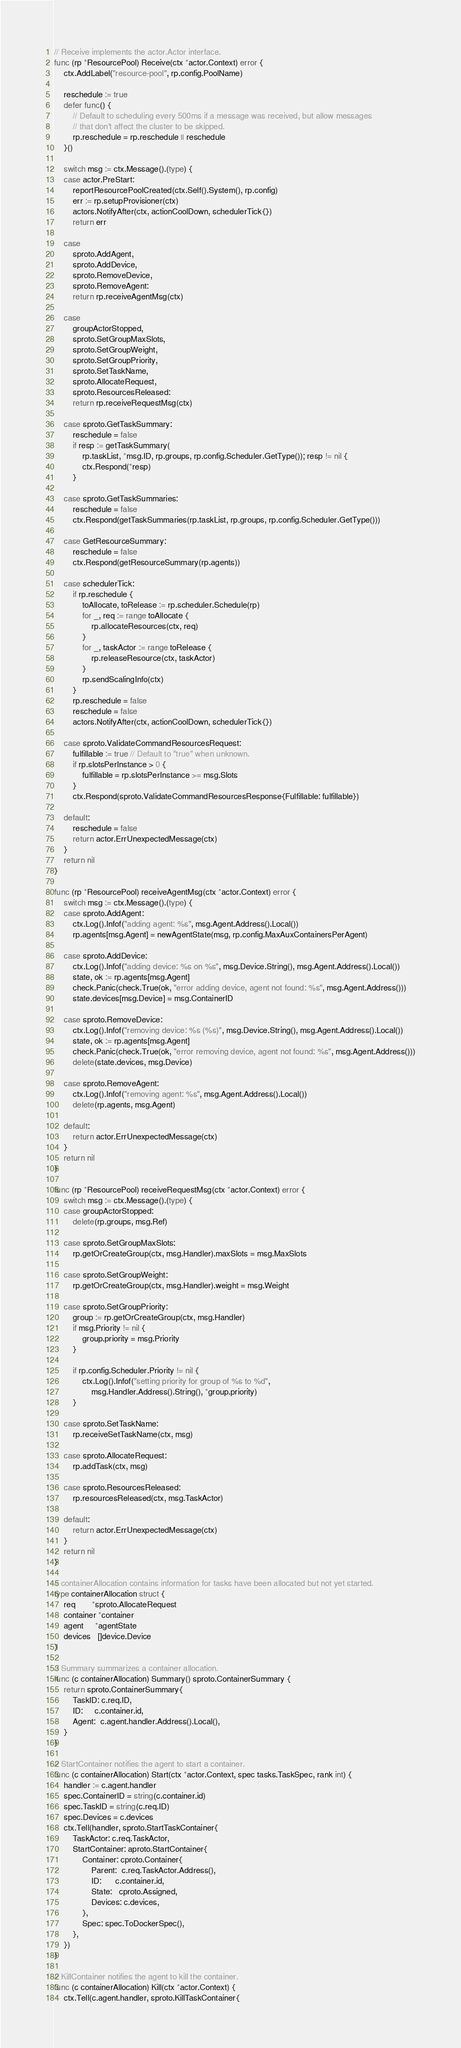<code> <loc_0><loc_0><loc_500><loc_500><_Go_>
// Receive implements the actor.Actor interface.
func (rp *ResourcePool) Receive(ctx *actor.Context) error {
	ctx.AddLabel("resource-pool", rp.config.PoolName)

	reschedule := true
	defer func() {
		// Default to scheduling every 500ms if a message was received, but allow messages
		// that don't affect the cluster to be skipped.
		rp.reschedule = rp.reschedule || reschedule
	}()

	switch msg := ctx.Message().(type) {
	case actor.PreStart:
		reportResourcePoolCreated(ctx.Self().System(), rp.config)
		err := rp.setupProvisioner(ctx)
		actors.NotifyAfter(ctx, actionCoolDown, schedulerTick{})
		return err

	case
		sproto.AddAgent,
		sproto.AddDevice,
		sproto.RemoveDevice,
		sproto.RemoveAgent:
		return rp.receiveAgentMsg(ctx)

	case
		groupActorStopped,
		sproto.SetGroupMaxSlots,
		sproto.SetGroupWeight,
		sproto.SetGroupPriority,
		sproto.SetTaskName,
		sproto.AllocateRequest,
		sproto.ResourcesReleased:
		return rp.receiveRequestMsg(ctx)

	case sproto.GetTaskSummary:
		reschedule = false
		if resp := getTaskSummary(
			rp.taskList, *msg.ID, rp.groups, rp.config.Scheduler.GetType()); resp != nil {
			ctx.Respond(*resp)
		}

	case sproto.GetTaskSummaries:
		reschedule = false
		ctx.Respond(getTaskSummaries(rp.taskList, rp.groups, rp.config.Scheduler.GetType()))

	case GetResourceSummary:
		reschedule = false
		ctx.Respond(getResourceSummary(rp.agents))

	case schedulerTick:
		if rp.reschedule {
			toAllocate, toRelease := rp.scheduler.Schedule(rp)
			for _, req := range toAllocate {
				rp.allocateResources(ctx, req)
			}
			for _, taskActor := range toRelease {
				rp.releaseResource(ctx, taskActor)
			}
			rp.sendScalingInfo(ctx)
		}
		rp.reschedule = false
		reschedule = false
		actors.NotifyAfter(ctx, actionCoolDown, schedulerTick{})

	case sproto.ValidateCommandResourcesRequest:
		fulfillable := true // Default to "true" when unknown.
		if rp.slotsPerInstance > 0 {
			fulfillable = rp.slotsPerInstance >= msg.Slots
		}
		ctx.Respond(sproto.ValidateCommandResourcesResponse{Fulfillable: fulfillable})

	default:
		reschedule = false
		return actor.ErrUnexpectedMessage(ctx)
	}
	return nil
}

func (rp *ResourcePool) receiveAgentMsg(ctx *actor.Context) error {
	switch msg := ctx.Message().(type) {
	case sproto.AddAgent:
		ctx.Log().Infof("adding agent: %s", msg.Agent.Address().Local())
		rp.agents[msg.Agent] = newAgentState(msg, rp.config.MaxAuxContainersPerAgent)

	case sproto.AddDevice:
		ctx.Log().Infof("adding device: %s on %s", msg.Device.String(), msg.Agent.Address().Local())
		state, ok := rp.agents[msg.Agent]
		check.Panic(check.True(ok, "error adding device, agent not found: %s", msg.Agent.Address()))
		state.devices[msg.Device] = msg.ContainerID

	case sproto.RemoveDevice:
		ctx.Log().Infof("removing device: %s (%s)", msg.Device.String(), msg.Agent.Address().Local())
		state, ok := rp.agents[msg.Agent]
		check.Panic(check.True(ok, "error removing device, agent not found: %s", msg.Agent.Address()))
		delete(state.devices, msg.Device)

	case sproto.RemoveAgent:
		ctx.Log().Infof("removing agent: %s", msg.Agent.Address().Local())
		delete(rp.agents, msg.Agent)

	default:
		return actor.ErrUnexpectedMessage(ctx)
	}
	return nil
}

func (rp *ResourcePool) receiveRequestMsg(ctx *actor.Context) error {
	switch msg := ctx.Message().(type) {
	case groupActorStopped:
		delete(rp.groups, msg.Ref)

	case sproto.SetGroupMaxSlots:
		rp.getOrCreateGroup(ctx, msg.Handler).maxSlots = msg.MaxSlots

	case sproto.SetGroupWeight:
		rp.getOrCreateGroup(ctx, msg.Handler).weight = msg.Weight

	case sproto.SetGroupPriority:
		group := rp.getOrCreateGroup(ctx, msg.Handler)
		if msg.Priority != nil {
			group.priority = msg.Priority
		}

		if rp.config.Scheduler.Priority != nil {
			ctx.Log().Infof("setting priority for group of %s to %d",
				msg.Handler.Address().String(), *group.priority)
		}

	case sproto.SetTaskName:
		rp.receiveSetTaskName(ctx, msg)

	case sproto.AllocateRequest:
		rp.addTask(ctx, msg)

	case sproto.ResourcesReleased:
		rp.resourcesReleased(ctx, msg.TaskActor)

	default:
		return actor.ErrUnexpectedMessage(ctx)
	}
	return nil
}

// containerAllocation contains information for tasks have been allocated but not yet started.
type containerAllocation struct {
	req       *sproto.AllocateRequest
	container *container
	agent     *agentState
	devices   []device.Device
}

// Summary summarizes a container allocation.
func (c containerAllocation) Summary() sproto.ContainerSummary {
	return sproto.ContainerSummary{
		TaskID: c.req.ID,
		ID:     c.container.id,
		Agent:  c.agent.handler.Address().Local(),
	}
}

// StartContainer notifies the agent to start a container.
func (c containerAllocation) Start(ctx *actor.Context, spec tasks.TaskSpec, rank int) {
	handler := c.agent.handler
	spec.ContainerID = string(c.container.id)
	spec.TaskID = string(c.req.ID)
	spec.Devices = c.devices
	ctx.Tell(handler, sproto.StartTaskContainer{
		TaskActor: c.req.TaskActor,
		StartContainer: aproto.StartContainer{
			Container: cproto.Container{
				Parent:  c.req.TaskActor.Address(),
				ID:      c.container.id,
				State:   cproto.Assigned,
				Devices: c.devices,
			},
			Spec: spec.ToDockerSpec(),
		},
	})
}

// KillContainer notifies the agent to kill the container.
func (c containerAllocation) Kill(ctx *actor.Context) {
	ctx.Tell(c.agent.handler, sproto.KillTaskContainer{</code> 